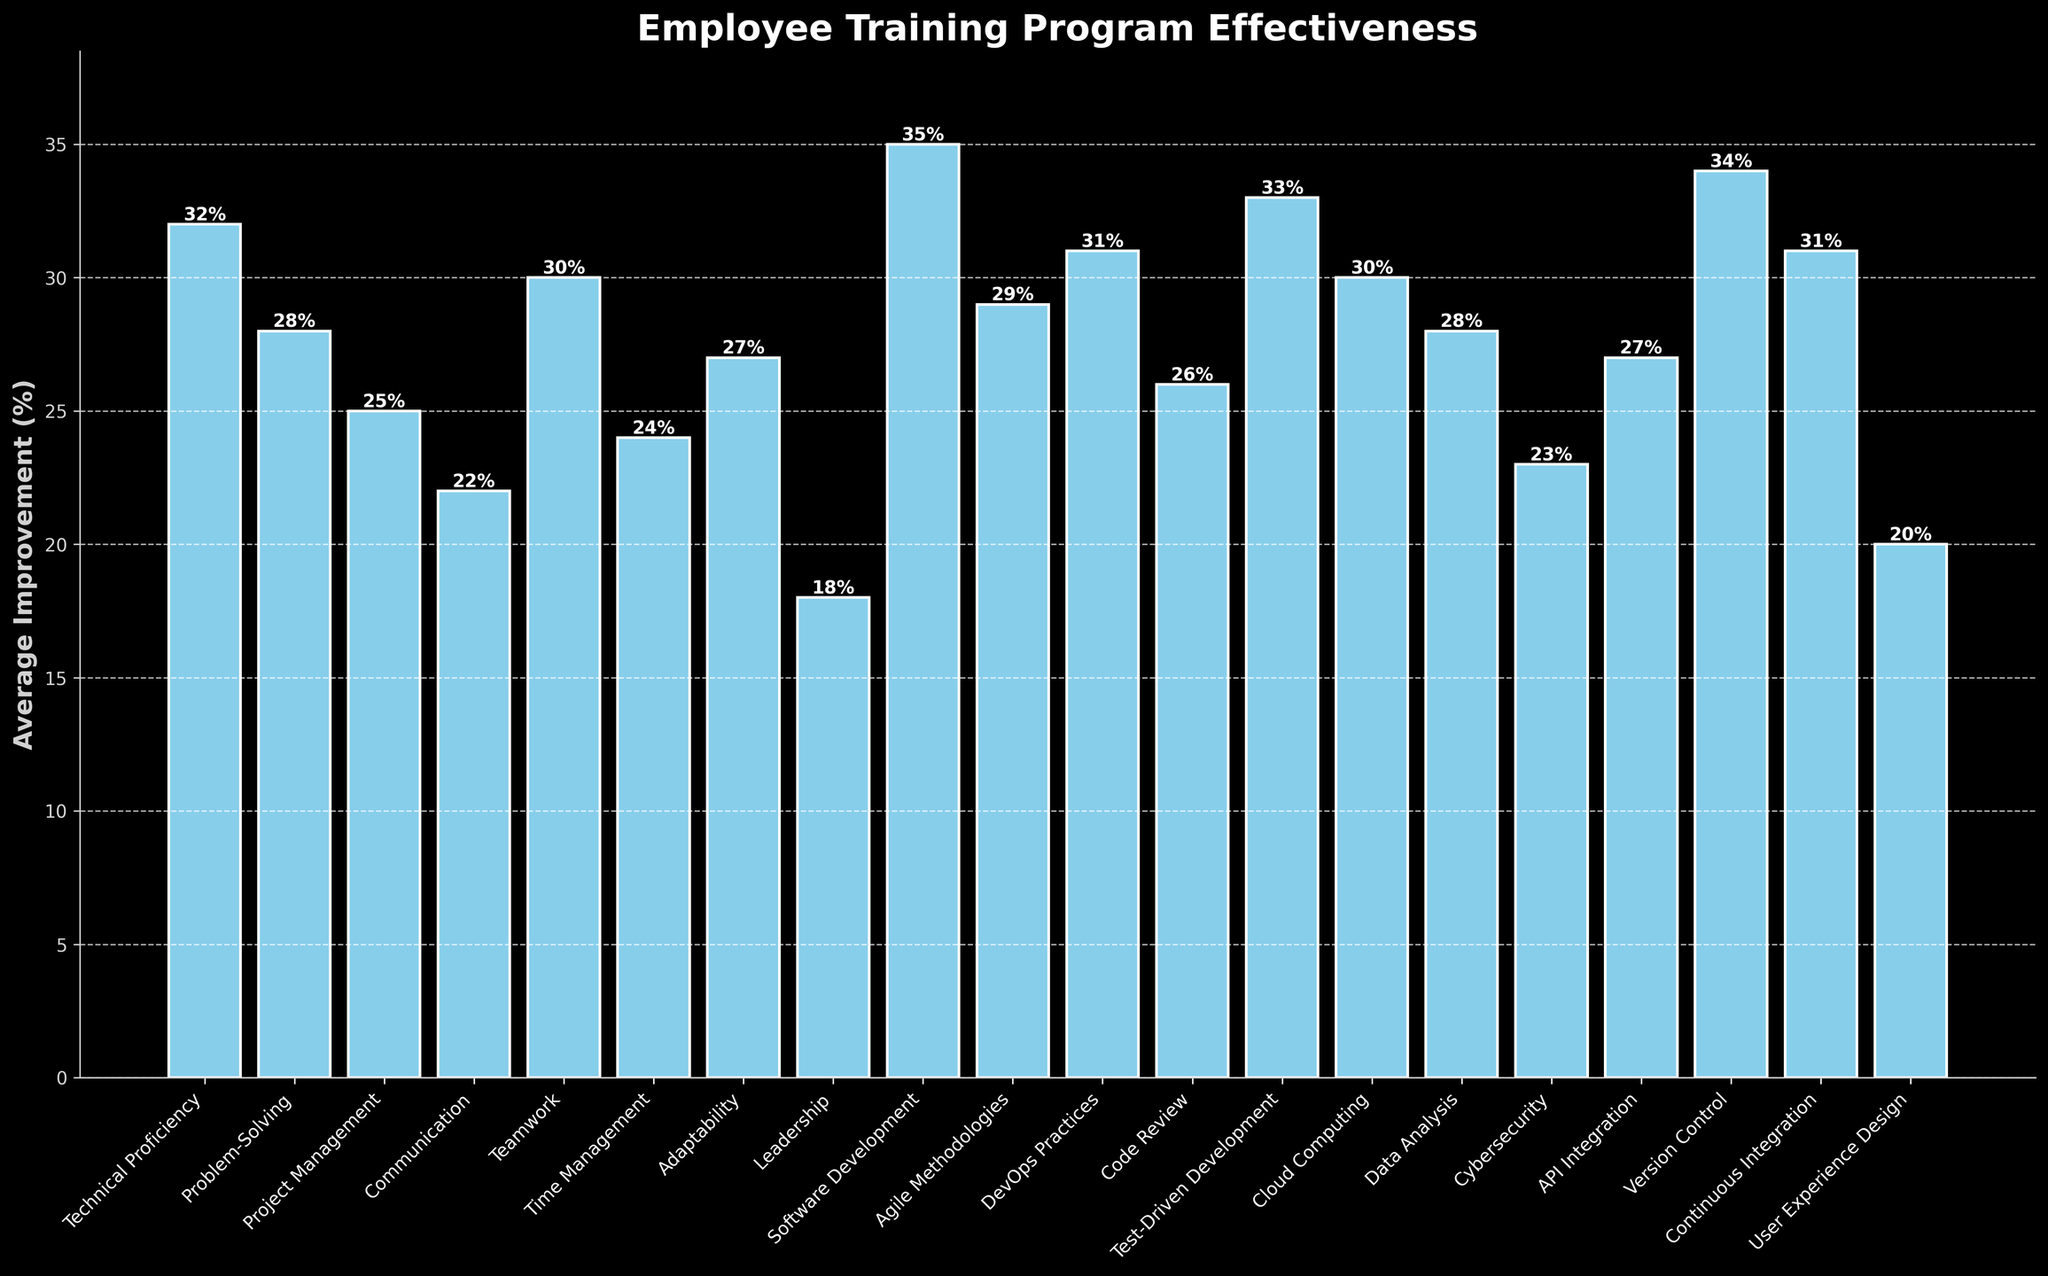Which skill showed the highest average improvement? Look at the bars in the chart and identify the tallest bar. The skill corresponding to this bar is Software Development with an improvement of 35%.
Answer: Software Development Which skill has the lowest average improvement? Look at the bars in the chart and identify the shortest bar. The skill corresponding to this bar is Leadership with an improvement of 18%.
Answer: Leadership What is the average improvement for Teamwork and Problem-Solving? First, locate the bars for Teamwork (30%) and Problem-Solving (28%). Add their improvement percentages and divide by 2: (30 + 28) / 2 = 29%.
Answer: 29% How much more improvement does Software Development show compared to Leadership? Find the improvement values for Software Development (35%) and Leadership (18%). Subtract the latter from the former: 35 - 18 = 17%.
Answer: 17% What is the total improvement for Agile Methodologies, Time Management, and Cybersecurity? Find the improvement values for Agile Methodologies (29%), Time Management (24%), and Cybersecurity (23%). Add them together: 29 + 24 + 23 = 76%.
Answer: 76% Which skills have an average improvement greater than 30%? Identify the bars with heights greater than 30%: Technical Proficiency (32%), Software Development (35%), Test-Driven Development (33%), Version Control (34%), Continuous Integration (31%), DevOps Practices (31%).
Answer: Technical Proficiency, Software Development, Test-Driven Development, Version Control, Continuous Integration, DevOps Practices Are there more skills with an average improvement below 25% or above 25%? Count the number of bars with improvements below 25%: Leadership (18%), Communication (22%), Cybersecurity (23%), User Experience Design (20%) — 4 skills. Count the number of bars with improvements above 25% — 16 skills. Compare the counts.
Answer: More above 25% Which skill shows an improvement closest to the average of all skills? Find the average improvement for all skills. Sum all improvement values and divide by 20: (32 + 28 + 25 + 22 + 30 + 24 + 27 + 18 + 35 + 29 + 31 + 26 + 33 + 30 + 28 + 23 + 27 + 34 + 31 + 20) / 20 = 27.5%. The skill with improvement closest to this value is Problem-Solving and Data Analysis, both at 28%.
Answer: Problem-Solving, Data Analysis What is the difference between the improvements of Communication and Teamwork? Locate the bars for Communication (22%) and Teamwork (30%). Compute the difference: 30 - 22 = 8%.
Answer: 8% Which skill had an improvement rate closest to 25%? Identify the bar whose height is closest to 25%. The skill corresponding to this is Project Management with an improvement of 25%.
Answer: Project Management 